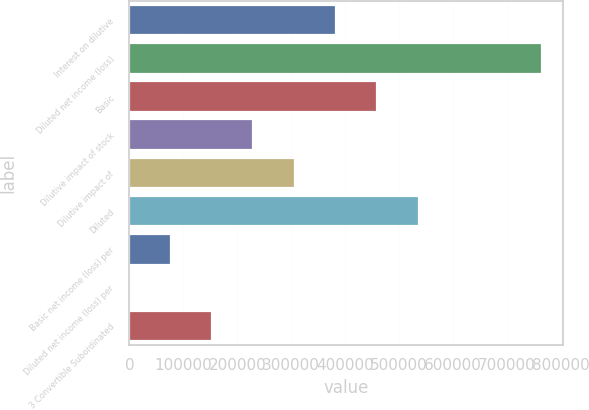<chart> <loc_0><loc_0><loc_500><loc_500><bar_chart><fcel>Interest on dilutive<fcel>Diluted net income (loss)<fcel>Basic<fcel>Dilutive impact of stock<fcel>Dilutive impact of<fcel>Diluted<fcel>Basic net income (loss) per<fcel>Diluted net income (loss) per<fcel>3 Convertible Subordinated<nl><fcel>382786<fcel>765571<fcel>459343<fcel>229672<fcel>306229<fcel>535900<fcel>76558.6<fcel>1.68<fcel>153116<nl></chart> 